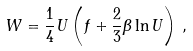Convert formula to latex. <formula><loc_0><loc_0><loc_500><loc_500>W = \frac { 1 } { 4 } U \left ( f + \frac { 2 } { 3 } \beta \ln U \right ) \, ,</formula> 